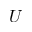<formula> <loc_0><loc_0><loc_500><loc_500>U</formula> 